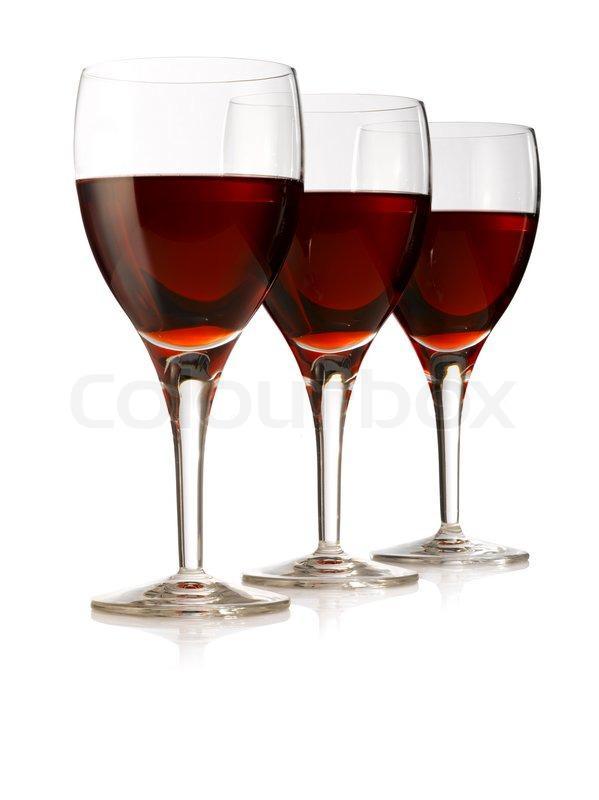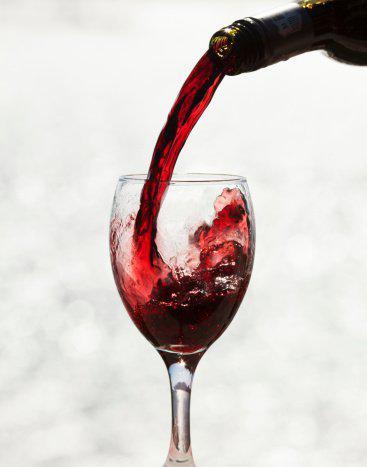The first image is the image on the left, the second image is the image on the right. Given the left and right images, does the statement "A bottle of wine is near at least one wine glass in one of the images." hold true? Answer yes or no. Yes. The first image is the image on the left, the second image is the image on the right. Given the left and right images, does the statement "An image depicts red wine splashing in a stemmed glass." hold true? Answer yes or no. Yes. 